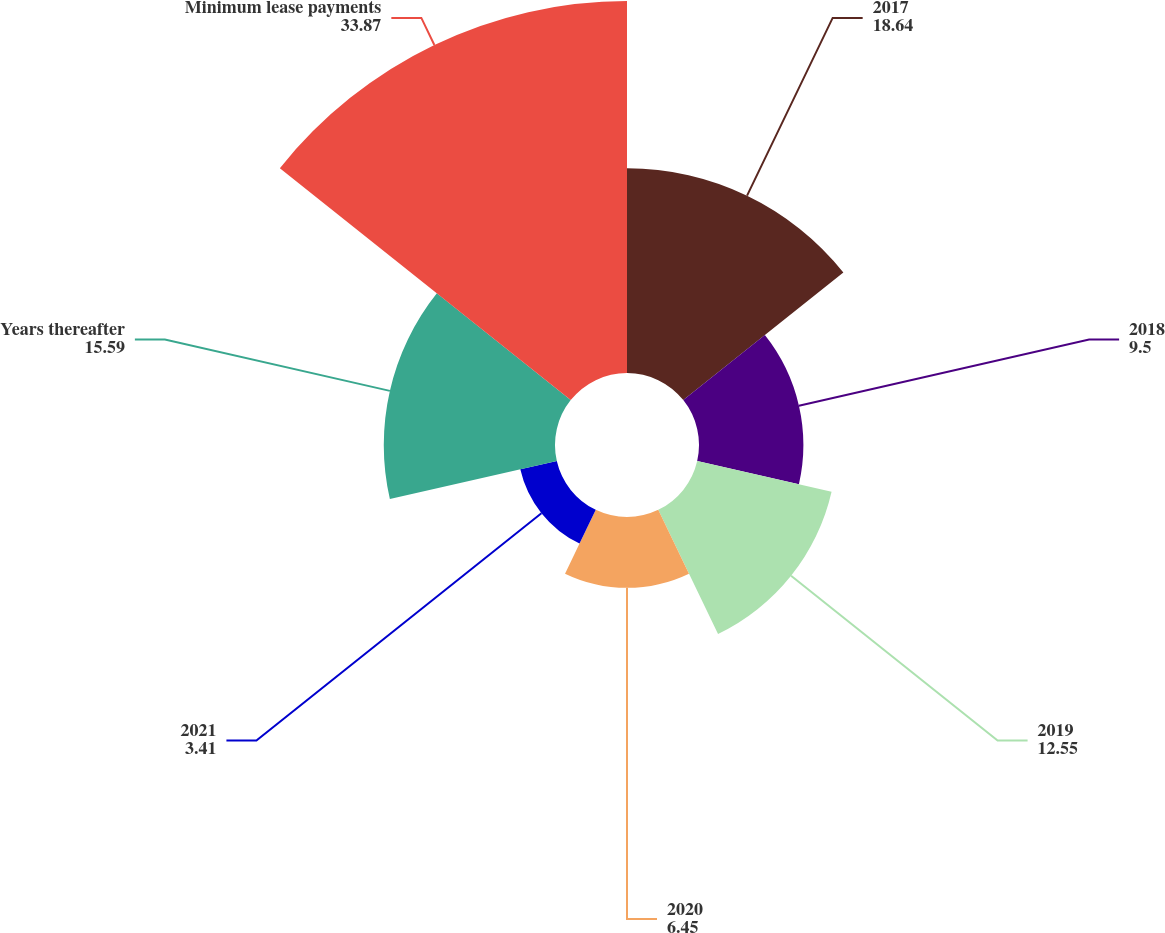Convert chart to OTSL. <chart><loc_0><loc_0><loc_500><loc_500><pie_chart><fcel>2017<fcel>2018<fcel>2019<fcel>2020<fcel>2021<fcel>Years thereafter<fcel>Minimum lease payments<nl><fcel>18.64%<fcel>9.5%<fcel>12.55%<fcel>6.45%<fcel>3.41%<fcel>15.59%<fcel>33.87%<nl></chart> 